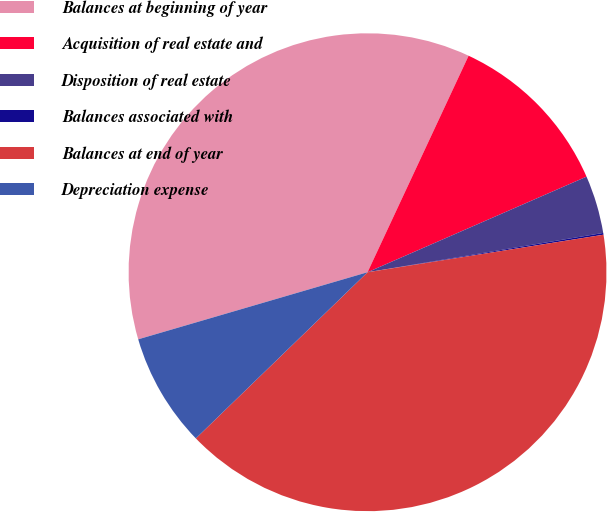Convert chart. <chart><loc_0><loc_0><loc_500><loc_500><pie_chart><fcel>Balances at beginning of year<fcel>Acquisition of real estate and<fcel>Disposition of real estate<fcel>Balances associated with<fcel>Balances at end of year<fcel>Depreciation expense<nl><fcel>36.48%<fcel>11.5%<fcel>3.92%<fcel>0.12%<fcel>40.27%<fcel>7.71%<nl></chart> 